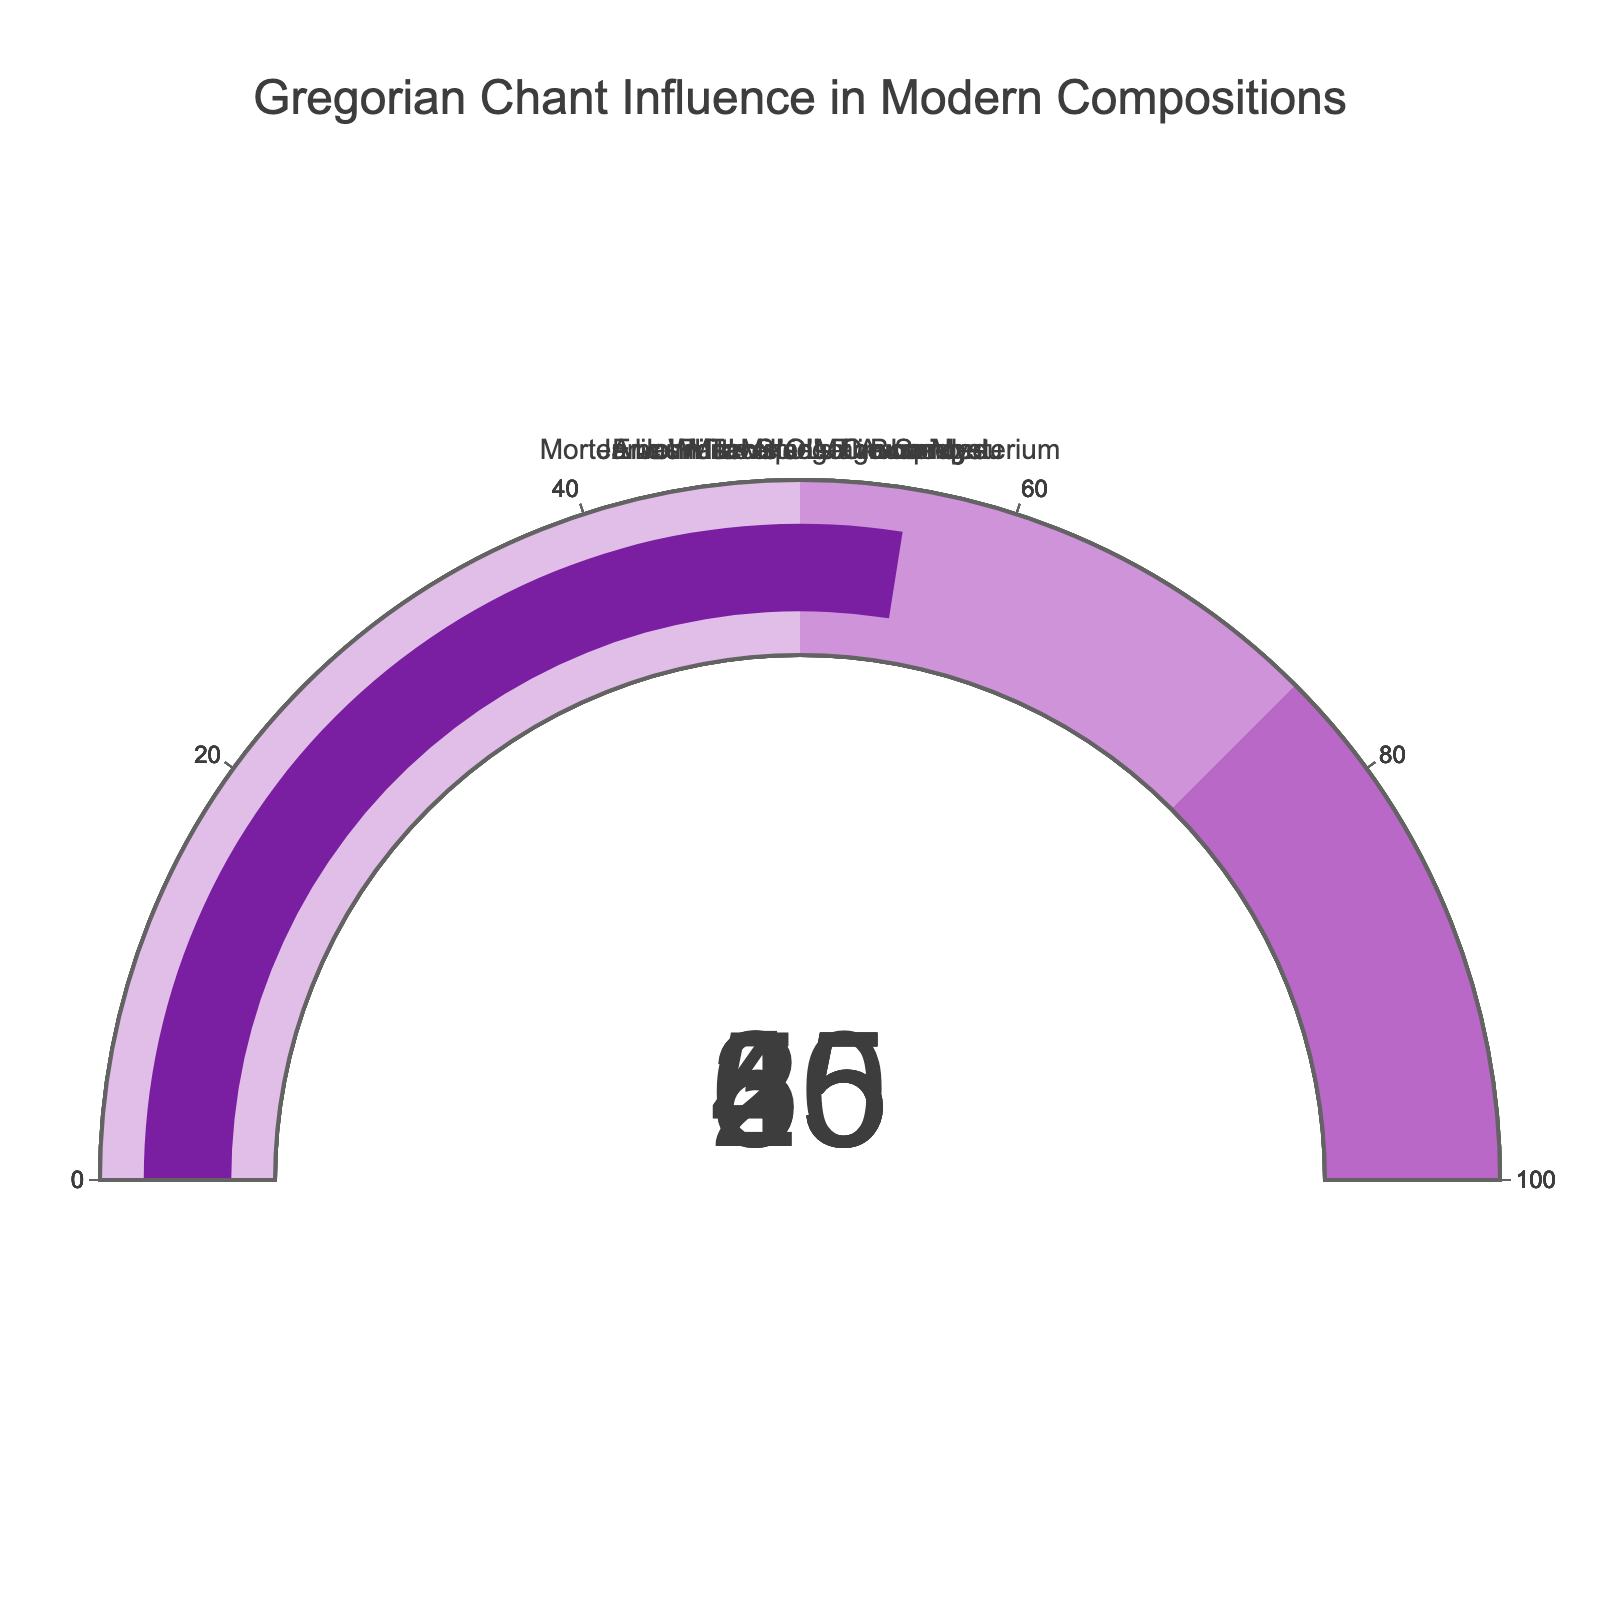what is the title of the chart? The title is displayed at the top of the chart.
Answer: Gregorian Chant Influence in Modern Compositions How many compositions are displayed in this chart? Each gauge represents one composition. Counting the gauges, we see there are 5 of them.
Answer: 5 Which composition has the highest influence percentage of Gregorian chant? By looking at the values displayed in each gauge, the highest one is 60%. The composition corresponding to this value is "John Tavener's The Lamb".
Answer: John Tavener's The Lamb What is the median percentage influence of Gregorian chant among the compositions? First, list the percentages: 25, 35, 45, 55, and 60. The median is the middle value when ordered, which is 45.
Answer: 45 By how much does "John Tavener's The Lamb" exceed "Eric Whitacre's Lux Aurumque" in Gregorian chant influence? "John Tavener's The Lamb" has 60% influence, and "Eric Whitacre's Lux Aurumque" has 25% influence. The difference is calculated as 60 - 25.
Answer: 35 Which compositions fall below the median influence percentage? The median value is 45%. Compositions with percentages below this are "Eric Whitacre's Lux Aurumque" (25%) and "Arvo Pärt's Spiegel im Spiegel" (35%).
Answer: Eric Whitacre's Lux Aurumque, Arvo Pärt's Spiegel im Spiegel What is the average percentage influence of Gregorian chant in these compositions? Sum up the percentages: 35 + 60 + 25 + 45 + 55 = 220. Divide by the number of compositions, which is 5. So, the average is 220 / 5.
Answer: 44 Which compositions have a Gregorian chant influence of more than 50%? By looking at the gauges, compositions with more than 50% influence are "John Tavener's The Lamb" (60%) and "James MacMillan's O Bone Jesu" (55%).
Answer: John Tavener's The Lamb, James MacMillan's O Bone Jesu How does the influence percentage of "Morten Lauridsen's O Magnum Mysterium" compare to the average percentage? The influence percentage for "Morten Lauridsen's O Magnum Mysterium" is 45%. The average percentage among all compositions is 44%. Since 45 > 44, it has a slightly higher influence.
Answer: Slightly higher 